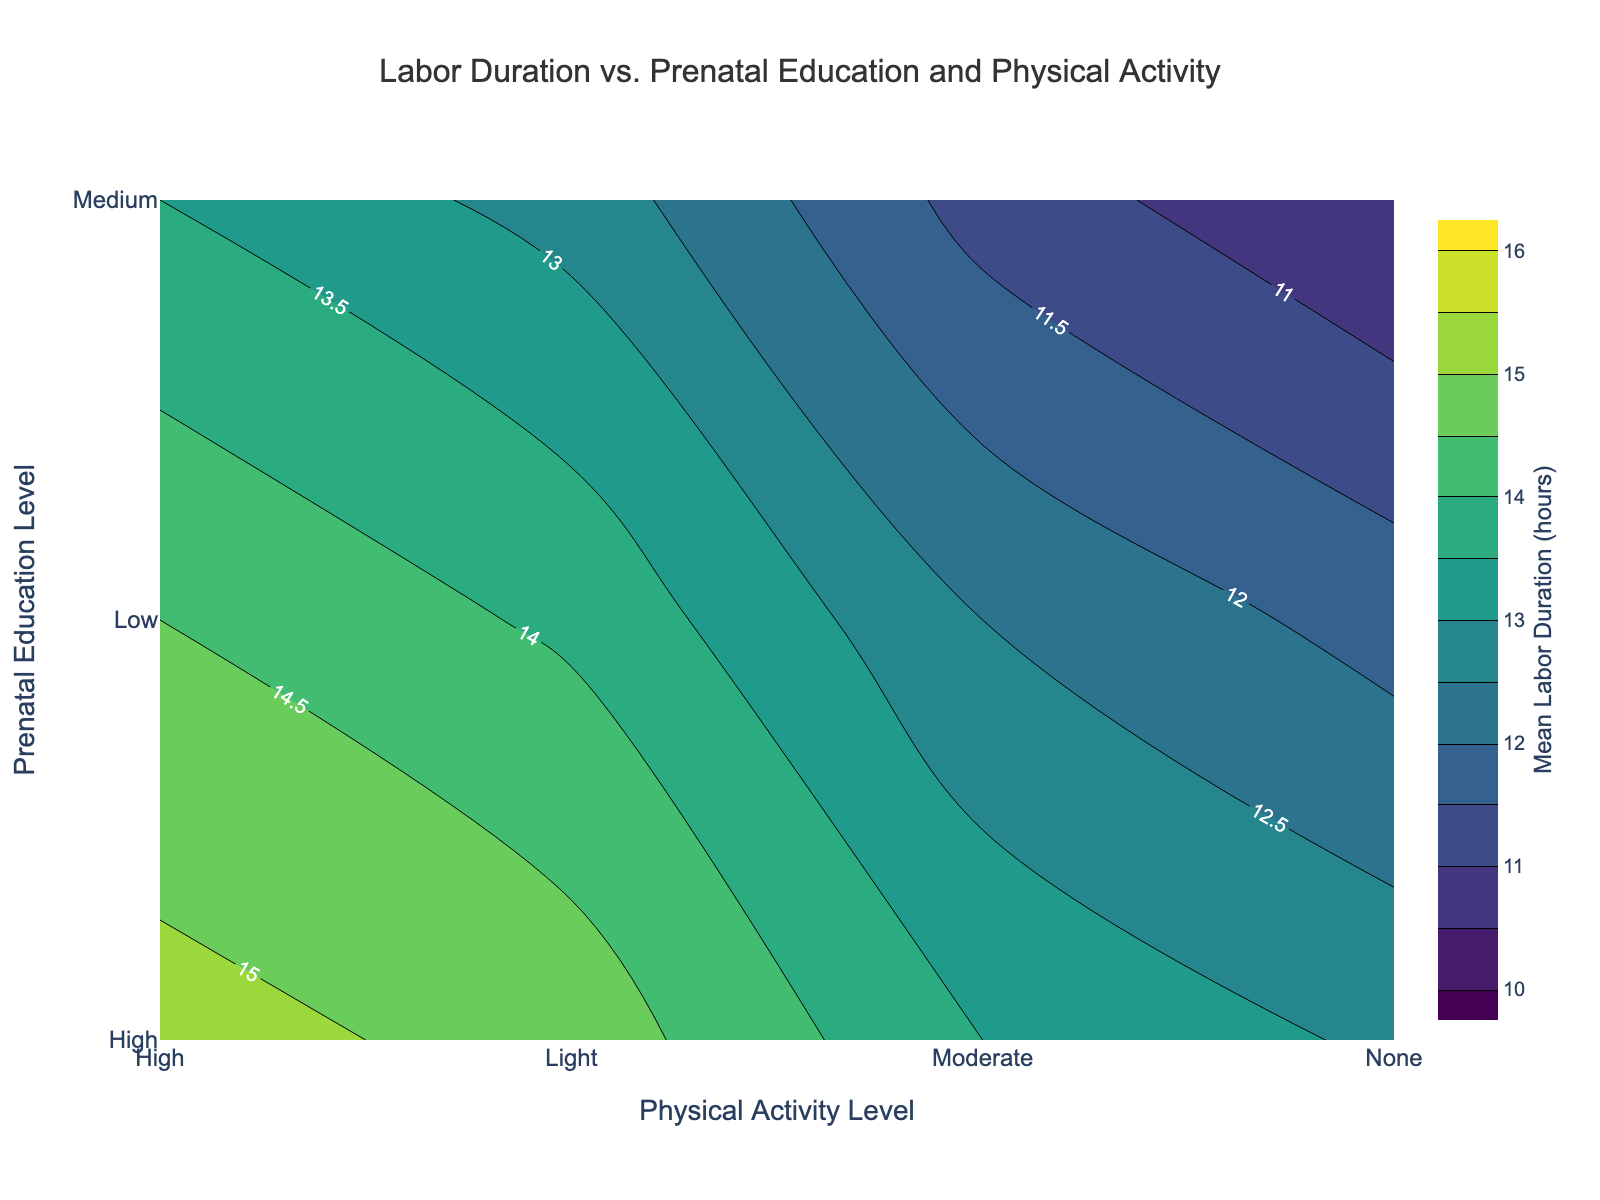What is the title of the figure? The title of the figure is located at the top and usually summarizes what the figure is showing. Here, it is related to labor duration, prenatal education, and physical activity.
Answer: Labor Duration vs. Prenatal Education and Physical Activity How does mean labor duration change from "None" to "High" physical activity for those with high prenatal education? To determine this, look at the contour labels for the "High" prenatal education level and observe the range of mean labor durations as physical activity levels increase from "None" to "High".
Answer: Decreases from 13.5 to 10.5 Based on the contour plot, which combination of prenatal education and physical activity level results in the shortest mean labor duration? The shortest mean labor duration can be identified by looking for the lowest value in the contour plot.
Answer: High prenatal education and High physical activity Which physical activity level shows the largest decrease in mean labor duration when comparing low and medium prenatal education levels? For each physical activity level, subtract the mean labor duration of low prenatal education from that of medium prenatal education, then identify which has the largest difference.
Answer: High What is the range of mean labor duration for individuals with medium prenatal education and moderate physical activity level? Locate the contour for "Medium" prenatal education and "Moderate" physical activity, then note the labeled mean labor duration value.
Answer: 12.5 hours How does the mean labor duration vary between low and high prenatal education, assuming no physical activity? The mean labor durations for "Low" and "High" prenatal education levels without physical activity must be compared directly from the contour plot.
Answer: Decreases from 15.2 to 13.5 hours Compare the impact of light physical activity on mean labor duration between low and medium prenatal education levels. Identify mean durations for light physical activity at both education levels and calculate the difference.
Answer: Decreases from 14.8 to 13.9 hours Which factor appears to have a more significant effect on reducing labor duration: increasing physical activity or increasing prenatal education? Observe the contour plot and compare how much mean labor duration drops with increased education versus increased physical activity.
Answer: Increasing physical activity If a participant has light physical activity, what is the expected reduction in mean labor duration when prenatal education increases from low to high? Find the mean labor durations for light physical activity at both low and high education levels, then subtract the values.
Answer: 14.8 - 12.8 = 2.0 hours 